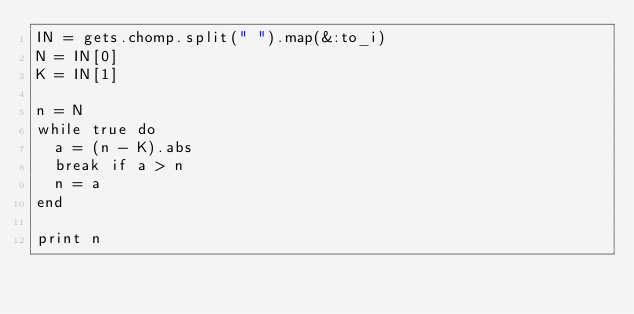Convert code to text. <code><loc_0><loc_0><loc_500><loc_500><_Ruby_>IN = gets.chomp.split(" ").map(&:to_i)
N = IN[0]
K = IN[1]

n = N
while true do
  a = (n - K).abs
  break if a > n
  n = a
end

print n</code> 